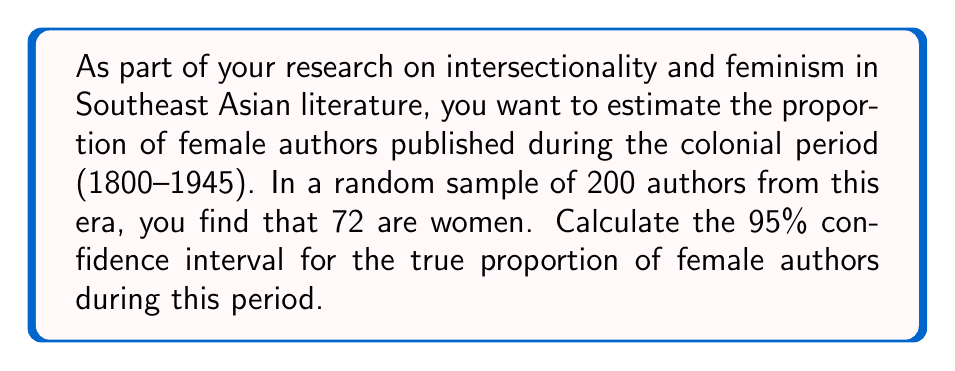Could you help me with this problem? Let's approach this step-by-step:

1) We're dealing with a proportion, so we'll use the formula for the confidence interval of a proportion:

   $$p \pm z \sqrt{\frac{p(1-p)}{n}}$$

   where $p$ is the sample proportion, $z$ is the z-score for the desired confidence level, and $n$ is the sample size.

2) Calculate the sample proportion $p$:
   $$p = \frac{72}{200} = 0.36$$

3) For a 95% confidence interval, the z-score is 1.96.

4) Our sample size $n$ is 200.

5) Now, let's plug these values into the formula:

   $$0.36 \pm 1.96 \sqrt{\frac{0.36(1-0.36)}{200}}$$

6) Simplify inside the square root:
   $$0.36 \pm 1.96 \sqrt{\frac{0.36(0.64)}{200}} = 0.36 \pm 1.96 \sqrt{0.001152}$$

7) Calculate:
   $$0.36 \pm 1.96(0.0339) = 0.36 \pm 0.0665$$

8) Therefore, the confidence interval is:
   $$(0.36 - 0.0665, 0.36 + 0.0665) = (0.2935, 0.4265)$$

We can be 95% confident that the true proportion of female authors during this period falls between 0.2935 and 0.4265, or approximately 29.35% to 42.65%.
Answer: (0.2935, 0.4265) 